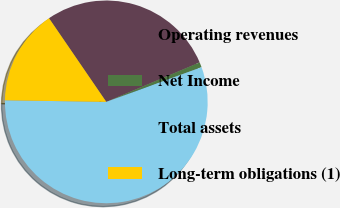Convert chart to OTSL. <chart><loc_0><loc_0><loc_500><loc_500><pie_chart><fcel>Operating revenues<fcel>Net Income<fcel>Total assets<fcel>Long-term obligations (1)<nl><fcel>28.19%<fcel>0.81%<fcel>55.81%<fcel>15.19%<nl></chart> 